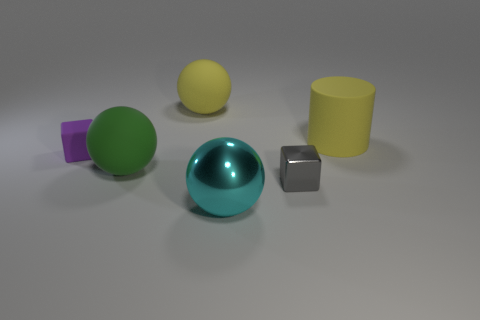Add 4 big shiny spheres. How many objects exist? 10 Subtract all cylinders. How many objects are left? 5 Add 1 shiny blocks. How many shiny blocks exist? 2 Subtract 0 blue cylinders. How many objects are left? 6 Subtract all small matte cubes. Subtract all yellow objects. How many objects are left? 3 Add 4 metallic things. How many metallic things are left? 6 